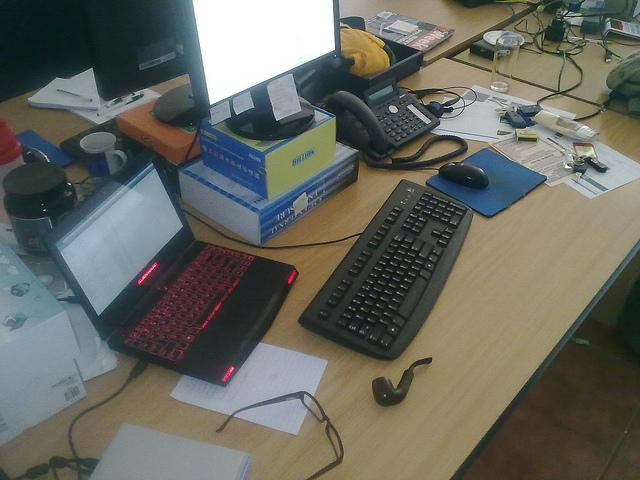What type of phone can this person use at the desk? landline 